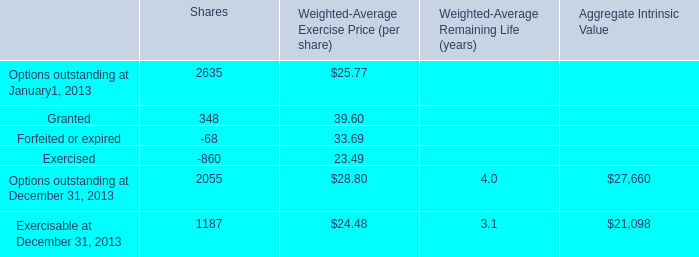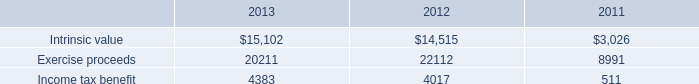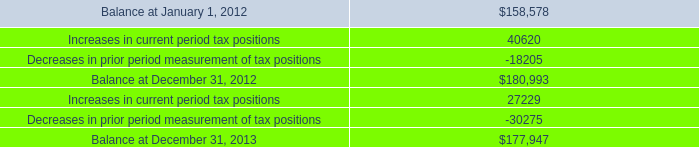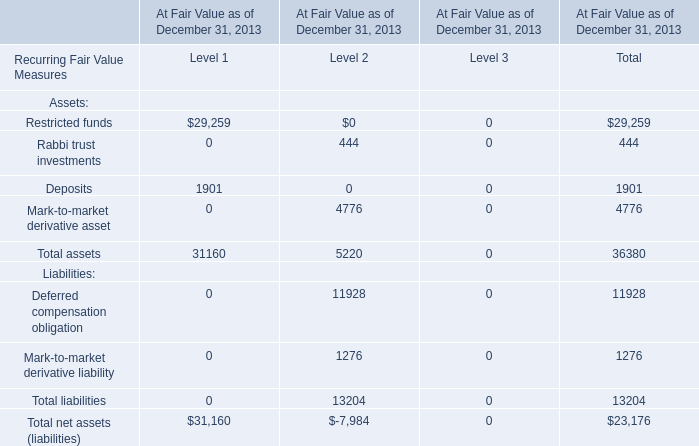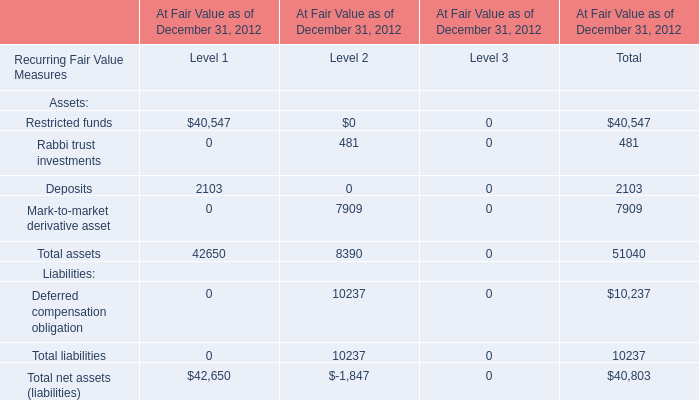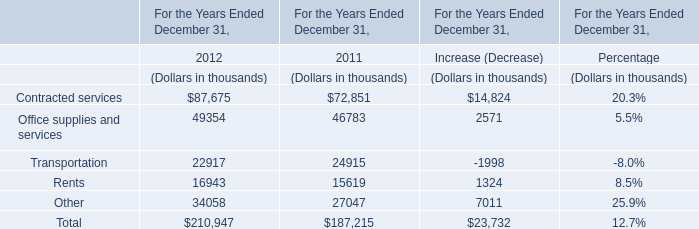What's the average of Increases in current period tax positions, and Exercise proceeds of 2012 ? 
Computations: ((27229.0 + 22112.0) / 2)
Answer: 24670.5. 